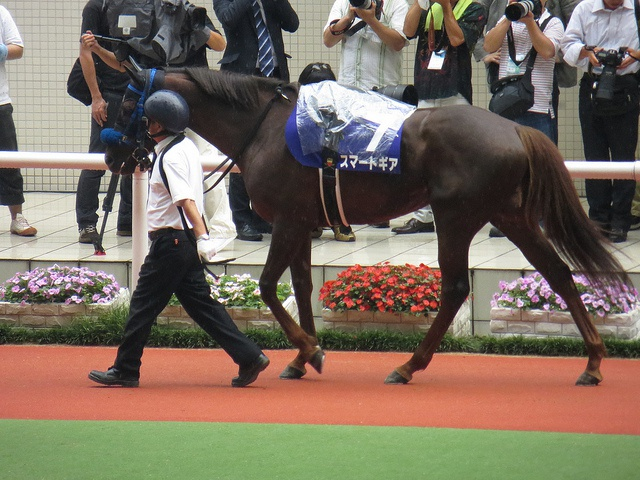Describe the objects in this image and their specific colors. I can see horse in darkgray, black, gray, and white tones, people in darkgray, black, white, and gray tones, people in darkgray, black, lightgray, and gray tones, potted plant in darkgray, gray, and lavender tones, and people in darkgray, black, maroon, and gray tones in this image. 